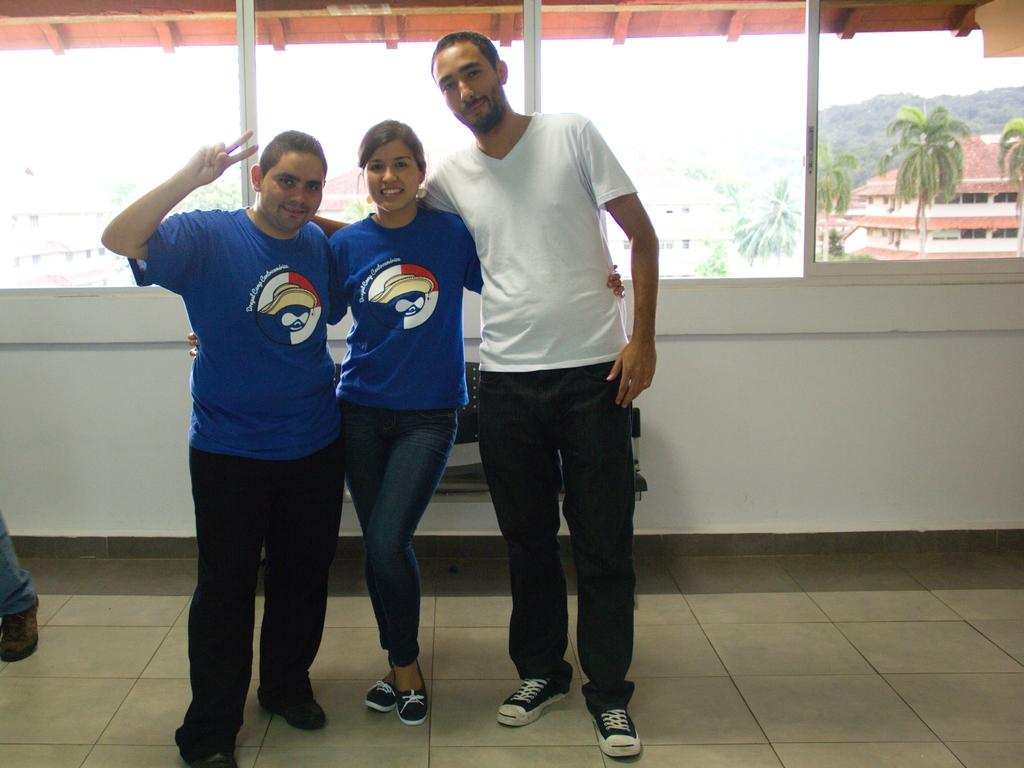How many people are in the image? There are three people standing in the image. What is the facial expression of the people in the image? The people are smiling. What can be seen at the back of the scene? There is a window at the back of the scene. What is visible in the background of the image? Trees, buildings, and the sky are visible in the background. Who is the owner of the balloon in the image? There is no balloon present in the image. In which direction are the people facing in the image? The provided facts do not specify the direction the people are facing; we can only see that they are standing and smiling. 